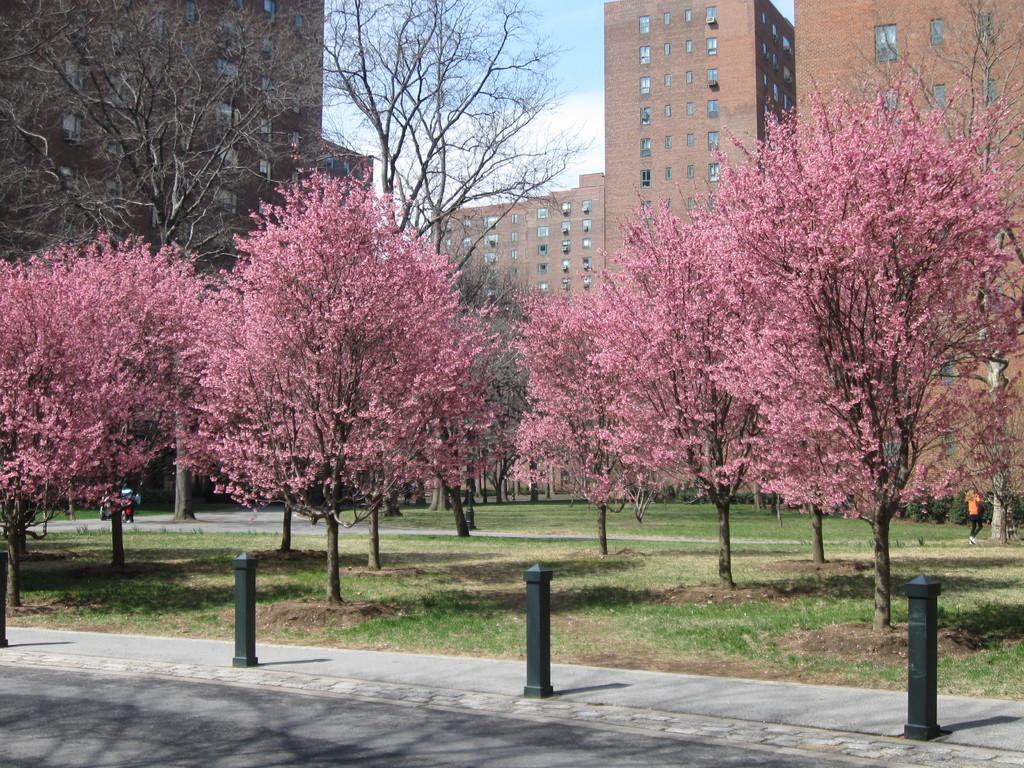Describe this image in one or two sentences. As we can see in the image there are trees, buildings, grass and sky. 